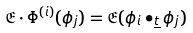Convert formula to latex. <formula><loc_0><loc_0><loc_500><loc_500>\mathfrak { E } \cdot \Phi ^ { ( i ) } ( \phi _ { j } ) = \mathfrak { E } ( \phi _ { i } \bullet _ { \underline { t } } \phi _ { j } )</formula> 